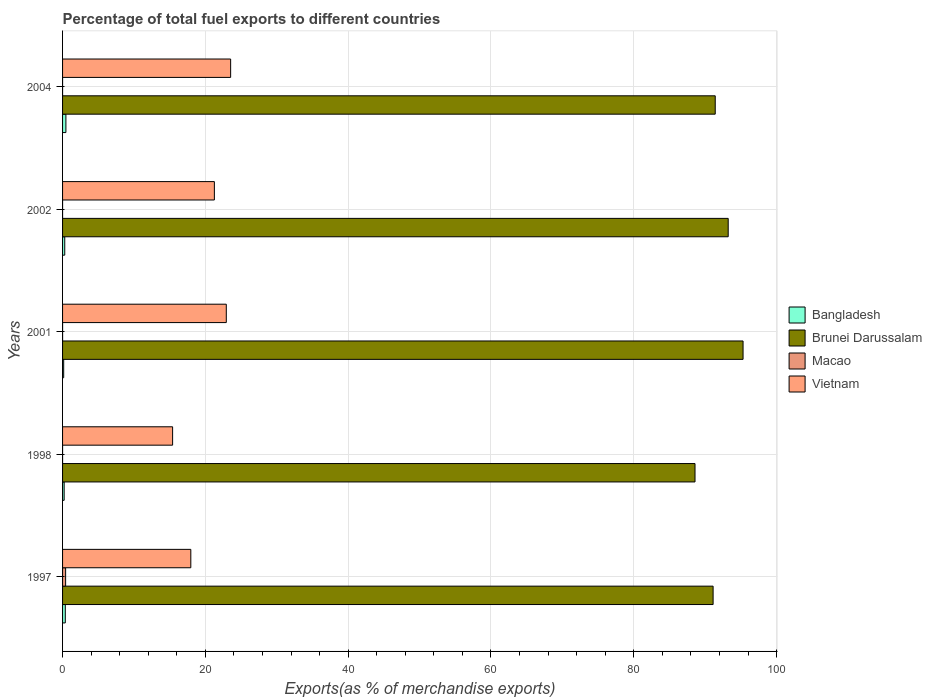How many different coloured bars are there?
Keep it short and to the point. 4. How many groups of bars are there?
Offer a terse response. 5. Are the number of bars on each tick of the Y-axis equal?
Give a very brief answer. Yes. How many bars are there on the 5th tick from the top?
Make the answer very short. 4. What is the percentage of exports to different countries in Macao in 2002?
Offer a terse response. 3.47856806115449e-5. Across all years, what is the maximum percentage of exports to different countries in Brunei Darussalam?
Offer a very short reply. 95.31. Across all years, what is the minimum percentage of exports to different countries in Macao?
Your response must be concise. 1.48205792325693e-5. What is the total percentage of exports to different countries in Macao in the graph?
Offer a terse response. 0.43. What is the difference between the percentage of exports to different countries in Vietnam in 1998 and that in 2004?
Provide a succinct answer. -8.13. What is the difference between the percentage of exports to different countries in Bangladesh in 1998 and the percentage of exports to different countries in Brunei Darussalam in 2001?
Your response must be concise. -95.08. What is the average percentage of exports to different countries in Brunei Darussalam per year?
Offer a terse response. 91.93. In the year 1997, what is the difference between the percentage of exports to different countries in Vietnam and percentage of exports to different countries in Macao?
Provide a succinct answer. 17.53. In how many years, is the percentage of exports to different countries in Macao greater than 72 %?
Offer a terse response. 0. What is the ratio of the percentage of exports to different countries in Macao in 2002 to that in 2004?
Give a very brief answer. 0.46. Is the percentage of exports to different countries in Bangladesh in 1998 less than that in 2001?
Offer a terse response. No. Is the difference between the percentage of exports to different countries in Vietnam in 2001 and 2004 greater than the difference between the percentage of exports to different countries in Macao in 2001 and 2004?
Your answer should be compact. No. What is the difference between the highest and the second highest percentage of exports to different countries in Vietnam?
Provide a succinct answer. 0.61. What is the difference between the highest and the lowest percentage of exports to different countries in Macao?
Offer a very short reply. 0.43. In how many years, is the percentage of exports to different countries in Brunei Darussalam greater than the average percentage of exports to different countries in Brunei Darussalam taken over all years?
Your answer should be very brief. 2. Is the sum of the percentage of exports to different countries in Vietnam in 1997 and 2004 greater than the maximum percentage of exports to different countries in Brunei Darussalam across all years?
Give a very brief answer. No. What does the 2nd bar from the bottom in 1998 represents?
Your response must be concise. Brunei Darussalam. Is it the case that in every year, the sum of the percentage of exports to different countries in Macao and percentage of exports to different countries in Bangladesh is greater than the percentage of exports to different countries in Vietnam?
Provide a succinct answer. No. Are all the bars in the graph horizontal?
Give a very brief answer. Yes. How many years are there in the graph?
Keep it short and to the point. 5. What is the difference between two consecutive major ticks on the X-axis?
Keep it short and to the point. 20. Are the values on the major ticks of X-axis written in scientific E-notation?
Provide a short and direct response. No. Where does the legend appear in the graph?
Offer a terse response. Center right. How many legend labels are there?
Offer a very short reply. 4. How are the legend labels stacked?
Provide a short and direct response. Vertical. What is the title of the graph?
Keep it short and to the point. Percentage of total fuel exports to different countries. What is the label or title of the X-axis?
Provide a succinct answer. Exports(as % of merchandise exports). What is the Exports(as % of merchandise exports) in Bangladesh in 1997?
Provide a succinct answer. 0.38. What is the Exports(as % of merchandise exports) in Brunei Darussalam in 1997?
Ensure brevity in your answer.  91.11. What is the Exports(as % of merchandise exports) in Macao in 1997?
Your response must be concise. 0.43. What is the Exports(as % of merchandise exports) of Vietnam in 1997?
Give a very brief answer. 17.96. What is the Exports(as % of merchandise exports) of Bangladesh in 1998?
Make the answer very short. 0.22. What is the Exports(as % of merchandise exports) in Brunei Darussalam in 1998?
Ensure brevity in your answer.  88.58. What is the Exports(as % of merchandise exports) in Macao in 1998?
Your answer should be very brief. 1.48205792325693e-5. What is the Exports(as % of merchandise exports) in Vietnam in 1998?
Offer a terse response. 15.41. What is the Exports(as % of merchandise exports) in Bangladesh in 2001?
Provide a succinct answer. 0.16. What is the Exports(as % of merchandise exports) of Brunei Darussalam in 2001?
Offer a very short reply. 95.31. What is the Exports(as % of merchandise exports) of Macao in 2001?
Provide a short and direct response. 0. What is the Exports(as % of merchandise exports) of Vietnam in 2001?
Give a very brief answer. 22.93. What is the Exports(as % of merchandise exports) of Bangladesh in 2002?
Offer a very short reply. 0.31. What is the Exports(as % of merchandise exports) of Brunei Darussalam in 2002?
Provide a succinct answer. 93.23. What is the Exports(as % of merchandise exports) in Macao in 2002?
Your answer should be compact. 3.47856806115449e-5. What is the Exports(as % of merchandise exports) of Vietnam in 2002?
Keep it short and to the point. 21.26. What is the Exports(as % of merchandise exports) in Bangladesh in 2004?
Your answer should be compact. 0.47. What is the Exports(as % of merchandise exports) of Brunei Darussalam in 2004?
Provide a short and direct response. 91.41. What is the Exports(as % of merchandise exports) in Macao in 2004?
Offer a terse response. 7.553903566299259e-5. What is the Exports(as % of merchandise exports) in Vietnam in 2004?
Your answer should be compact. 23.54. Across all years, what is the maximum Exports(as % of merchandise exports) of Bangladesh?
Ensure brevity in your answer.  0.47. Across all years, what is the maximum Exports(as % of merchandise exports) in Brunei Darussalam?
Provide a short and direct response. 95.31. Across all years, what is the maximum Exports(as % of merchandise exports) of Macao?
Keep it short and to the point. 0.43. Across all years, what is the maximum Exports(as % of merchandise exports) of Vietnam?
Provide a short and direct response. 23.54. Across all years, what is the minimum Exports(as % of merchandise exports) of Bangladesh?
Offer a terse response. 0.16. Across all years, what is the minimum Exports(as % of merchandise exports) of Brunei Darussalam?
Ensure brevity in your answer.  88.58. Across all years, what is the minimum Exports(as % of merchandise exports) in Macao?
Your answer should be compact. 1.48205792325693e-5. Across all years, what is the minimum Exports(as % of merchandise exports) in Vietnam?
Your answer should be compact. 15.41. What is the total Exports(as % of merchandise exports) in Bangladesh in the graph?
Offer a terse response. 1.54. What is the total Exports(as % of merchandise exports) in Brunei Darussalam in the graph?
Make the answer very short. 459.63. What is the total Exports(as % of merchandise exports) in Macao in the graph?
Your answer should be compact. 0.43. What is the total Exports(as % of merchandise exports) in Vietnam in the graph?
Keep it short and to the point. 101.11. What is the difference between the Exports(as % of merchandise exports) in Bangladesh in 1997 and that in 1998?
Ensure brevity in your answer.  0.16. What is the difference between the Exports(as % of merchandise exports) in Brunei Darussalam in 1997 and that in 1998?
Offer a very short reply. 2.53. What is the difference between the Exports(as % of merchandise exports) of Macao in 1997 and that in 1998?
Ensure brevity in your answer.  0.43. What is the difference between the Exports(as % of merchandise exports) of Vietnam in 1997 and that in 1998?
Provide a short and direct response. 2.55. What is the difference between the Exports(as % of merchandise exports) of Bangladesh in 1997 and that in 2001?
Provide a succinct answer. 0.23. What is the difference between the Exports(as % of merchandise exports) in Brunei Darussalam in 1997 and that in 2001?
Give a very brief answer. -4.19. What is the difference between the Exports(as % of merchandise exports) of Macao in 1997 and that in 2001?
Make the answer very short. 0.43. What is the difference between the Exports(as % of merchandise exports) of Vietnam in 1997 and that in 2001?
Make the answer very short. -4.97. What is the difference between the Exports(as % of merchandise exports) of Bangladesh in 1997 and that in 2002?
Make the answer very short. 0.08. What is the difference between the Exports(as % of merchandise exports) in Brunei Darussalam in 1997 and that in 2002?
Your response must be concise. -2.11. What is the difference between the Exports(as % of merchandise exports) in Macao in 1997 and that in 2002?
Your answer should be very brief. 0.43. What is the difference between the Exports(as % of merchandise exports) in Vietnam in 1997 and that in 2002?
Give a very brief answer. -3.3. What is the difference between the Exports(as % of merchandise exports) in Bangladesh in 1997 and that in 2004?
Your answer should be very brief. -0.09. What is the difference between the Exports(as % of merchandise exports) of Brunei Darussalam in 1997 and that in 2004?
Offer a terse response. -0.3. What is the difference between the Exports(as % of merchandise exports) of Macao in 1997 and that in 2004?
Your answer should be very brief. 0.43. What is the difference between the Exports(as % of merchandise exports) of Vietnam in 1997 and that in 2004?
Keep it short and to the point. -5.58. What is the difference between the Exports(as % of merchandise exports) in Bangladesh in 1998 and that in 2001?
Offer a very short reply. 0.07. What is the difference between the Exports(as % of merchandise exports) in Brunei Darussalam in 1998 and that in 2001?
Provide a succinct answer. -6.73. What is the difference between the Exports(as % of merchandise exports) in Macao in 1998 and that in 2001?
Offer a very short reply. -0. What is the difference between the Exports(as % of merchandise exports) in Vietnam in 1998 and that in 2001?
Give a very brief answer. -7.52. What is the difference between the Exports(as % of merchandise exports) of Bangladesh in 1998 and that in 2002?
Provide a succinct answer. -0.08. What is the difference between the Exports(as % of merchandise exports) of Brunei Darussalam in 1998 and that in 2002?
Keep it short and to the point. -4.65. What is the difference between the Exports(as % of merchandise exports) in Vietnam in 1998 and that in 2002?
Your response must be concise. -5.85. What is the difference between the Exports(as % of merchandise exports) of Bangladesh in 1998 and that in 2004?
Offer a very short reply. -0.25. What is the difference between the Exports(as % of merchandise exports) of Brunei Darussalam in 1998 and that in 2004?
Offer a very short reply. -2.83. What is the difference between the Exports(as % of merchandise exports) in Macao in 1998 and that in 2004?
Your answer should be very brief. -0. What is the difference between the Exports(as % of merchandise exports) of Vietnam in 1998 and that in 2004?
Provide a short and direct response. -8.13. What is the difference between the Exports(as % of merchandise exports) of Bangladesh in 2001 and that in 2002?
Ensure brevity in your answer.  -0.15. What is the difference between the Exports(as % of merchandise exports) in Brunei Darussalam in 2001 and that in 2002?
Make the answer very short. 2.08. What is the difference between the Exports(as % of merchandise exports) in Macao in 2001 and that in 2002?
Provide a succinct answer. 0. What is the difference between the Exports(as % of merchandise exports) of Vietnam in 2001 and that in 2002?
Offer a very short reply. 1.67. What is the difference between the Exports(as % of merchandise exports) of Bangladesh in 2001 and that in 2004?
Offer a very short reply. -0.31. What is the difference between the Exports(as % of merchandise exports) of Brunei Darussalam in 2001 and that in 2004?
Offer a very short reply. 3.9. What is the difference between the Exports(as % of merchandise exports) of Vietnam in 2001 and that in 2004?
Provide a short and direct response. -0.61. What is the difference between the Exports(as % of merchandise exports) in Bangladesh in 2002 and that in 2004?
Provide a short and direct response. -0.16. What is the difference between the Exports(as % of merchandise exports) of Brunei Darussalam in 2002 and that in 2004?
Offer a very short reply. 1.82. What is the difference between the Exports(as % of merchandise exports) of Vietnam in 2002 and that in 2004?
Give a very brief answer. -2.28. What is the difference between the Exports(as % of merchandise exports) of Bangladesh in 1997 and the Exports(as % of merchandise exports) of Brunei Darussalam in 1998?
Ensure brevity in your answer.  -88.19. What is the difference between the Exports(as % of merchandise exports) in Bangladesh in 1997 and the Exports(as % of merchandise exports) in Macao in 1998?
Your answer should be very brief. 0.38. What is the difference between the Exports(as % of merchandise exports) in Bangladesh in 1997 and the Exports(as % of merchandise exports) in Vietnam in 1998?
Provide a short and direct response. -15.03. What is the difference between the Exports(as % of merchandise exports) of Brunei Darussalam in 1997 and the Exports(as % of merchandise exports) of Macao in 1998?
Provide a succinct answer. 91.11. What is the difference between the Exports(as % of merchandise exports) of Brunei Darussalam in 1997 and the Exports(as % of merchandise exports) of Vietnam in 1998?
Provide a short and direct response. 75.7. What is the difference between the Exports(as % of merchandise exports) in Macao in 1997 and the Exports(as % of merchandise exports) in Vietnam in 1998?
Offer a terse response. -14.99. What is the difference between the Exports(as % of merchandise exports) in Bangladesh in 1997 and the Exports(as % of merchandise exports) in Brunei Darussalam in 2001?
Your answer should be compact. -94.92. What is the difference between the Exports(as % of merchandise exports) of Bangladesh in 1997 and the Exports(as % of merchandise exports) of Macao in 2001?
Ensure brevity in your answer.  0.38. What is the difference between the Exports(as % of merchandise exports) of Bangladesh in 1997 and the Exports(as % of merchandise exports) of Vietnam in 2001?
Ensure brevity in your answer.  -22.55. What is the difference between the Exports(as % of merchandise exports) in Brunei Darussalam in 1997 and the Exports(as % of merchandise exports) in Macao in 2001?
Keep it short and to the point. 91.11. What is the difference between the Exports(as % of merchandise exports) of Brunei Darussalam in 1997 and the Exports(as % of merchandise exports) of Vietnam in 2001?
Provide a short and direct response. 68.18. What is the difference between the Exports(as % of merchandise exports) in Macao in 1997 and the Exports(as % of merchandise exports) in Vietnam in 2001?
Offer a very short reply. -22.5. What is the difference between the Exports(as % of merchandise exports) in Bangladesh in 1997 and the Exports(as % of merchandise exports) in Brunei Darussalam in 2002?
Your answer should be very brief. -92.84. What is the difference between the Exports(as % of merchandise exports) of Bangladesh in 1997 and the Exports(as % of merchandise exports) of Macao in 2002?
Ensure brevity in your answer.  0.38. What is the difference between the Exports(as % of merchandise exports) in Bangladesh in 1997 and the Exports(as % of merchandise exports) in Vietnam in 2002?
Make the answer very short. -20.88. What is the difference between the Exports(as % of merchandise exports) in Brunei Darussalam in 1997 and the Exports(as % of merchandise exports) in Macao in 2002?
Your answer should be compact. 91.11. What is the difference between the Exports(as % of merchandise exports) in Brunei Darussalam in 1997 and the Exports(as % of merchandise exports) in Vietnam in 2002?
Give a very brief answer. 69.85. What is the difference between the Exports(as % of merchandise exports) in Macao in 1997 and the Exports(as % of merchandise exports) in Vietnam in 2002?
Provide a succinct answer. -20.83. What is the difference between the Exports(as % of merchandise exports) of Bangladesh in 1997 and the Exports(as % of merchandise exports) of Brunei Darussalam in 2004?
Your answer should be very brief. -91.03. What is the difference between the Exports(as % of merchandise exports) of Bangladesh in 1997 and the Exports(as % of merchandise exports) of Macao in 2004?
Your answer should be very brief. 0.38. What is the difference between the Exports(as % of merchandise exports) in Bangladesh in 1997 and the Exports(as % of merchandise exports) in Vietnam in 2004?
Your answer should be very brief. -23.16. What is the difference between the Exports(as % of merchandise exports) of Brunei Darussalam in 1997 and the Exports(as % of merchandise exports) of Macao in 2004?
Your answer should be very brief. 91.11. What is the difference between the Exports(as % of merchandise exports) of Brunei Darussalam in 1997 and the Exports(as % of merchandise exports) of Vietnam in 2004?
Give a very brief answer. 67.57. What is the difference between the Exports(as % of merchandise exports) in Macao in 1997 and the Exports(as % of merchandise exports) in Vietnam in 2004?
Give a very brief answer. -23.11. What is the difference between the Exports(as % of merchandise exports) in Bangladesh in 1998 and the Exports(as % of merchandise exports) in Brunei Darussalam in 2001?
Your answer should be very brief. -95.08. What is the difference between the Exports(as % of merchandise exports) in Bangladesh in 1998 and the Exports(as % of merchandise exports) in Macao in 2001?
Offer a very short reply. 0.22. What is the difference between the Exports(as % of merchandise exports) in Bangladesh in 1998 and the Exports(as % of merchandise exports) in Vietnam in 2001?
Provide a short and direct response. -22.71. What is the difference between the Exports(as % of merchandise exports) in Brunei Darussalam in 1998 and the Exports(as % of merchandise exports) in Macao in 2001?
Provide a succinct answer. 88.58. What is the difference between the Exports(as % of merchandise exports) of Brunei Darussalam in 1998 and the Exports(as % of merchandise exports) of Vietnam in 2001?
Ensure brevity in your answer.  65.65. What is the difference between the Exports(as % of merchandise exports) in Macao in 1998 and the Exports(as % of merchandise exports) in Vietnam in 2001?
Ensure brevity in your answer.  -22.93. What is the difference between the Exports(as % of merchandise exports) of Bangladesh in 1998 and the Exports(as % of merchandise exports) of Brunei Darussalam in 2002?
Provide a succinct answer. -93. What is the difference between the Exports(as % of merchandise exports) in Bangladesh in 1998 and the Exports(as % of merchandise exports) in Macao in 2002?
Keep it short and to the point. 0.22. What is the difference between the Exports(as % of merchandise exports) in Bangladesh in 1998 and the Exports(as % of merchandise exports) in Vietnam in 2002?
Give a very brief answer. -21.04. What is the difference between the Exports(as % of merchandise exports) in Brunei Darussalam in 1998 and the Exports(as % of merchandise exports) in Macao in 2002?
Offer a terse response. 88.58. What is the difference between the Exports(as % of merchandise exports) of Brunei Darussalam in 1998 and the Exports(as % of merchandise exports) of Vietnam in 2002?
Provide a short and direct response. 67.31. What is the difference between the Exports(as % of merchandise exports) in Macao in 1998 and the Exports(as % of merchandise exports) in Vietnam in 2002?
Your answer should be very brief. -21.26. What is the difference between the Exports(as % of merchandise exports) of Bangladesh in 1998 and the Exports(as % of merchandise exports) of Brunei Darussalam in 2004?
Provide a short and direct response. -91.19. What is the difference between the Exports(as % of merchandise exports) in Bangladesh in 1998 and the Exports(as % of merchandise exports) in Macao in 2004?
Your answer should be compact. 0.22. What is the difference between the Exports(as % of merchandise exports) in Bangladesh in 1998 and the Exports(as % of merchandise exports) in Vietnam in 2004?
Offer a very short reply. -23.32. What is the difference between the Exports(as % of merchandise exports) of Brunei Darussalam in 1998 and the Exports(as % of merchandise exports) of Macao in 2004?
Give a very brief answer. 88.58. What is the difference between the Exports(as % of merchandise exports) in Brunei Darussalam in 1998 and the Exports(as % of merchandise exports) in Vietnam in 2004?
Your response must be concise. 65.04. What is the difference between the Exports(as % of merchandise exports) of Macao in 1998 and the Exports(as % of merchandise exports) of Vietnam in 2004?
Provide a succinct answer. -23.54. What is the difference between the Exports(as % of merchandise exports) in Bangladesh in 2001 and the Exports(as % of merchandise exports) in Brunei Darussalam in 2002?
Provide a short and direct response. -93.07. What is the difference between the Exports(as % of merchandise exports) in Bangladesh in 2001 and the Exports(as % of merchandise exports) in Macao in 2002?
Your answer should be very brief. 0.16. What is the difference between the Exports(as % of merchandise exports) in Bangladesh in 2001 and the Exports(as % of merchandise exports) in Vietnam in 2002?
Your answer should be compact. -21.11. What is the difference between the Exports(as % of merchandise exports) of Brunei Darussalam in 2001 and the Exports(as % of merchandise exports) of Macao in 2002?
Provide a short and direct response. 95.31. What is the difference between the Exports(as % of merchandise exports) in Brunei Darussalam in 2001 and the Exports(as % of merchandise exports) in Vietnam in 2002?
Give a very brief answer. 74.04. What is the difference between the Exports(as % of merchandise exports) of Macao in 2001 and the Exports(as % of merchandise exports) of Vietnam in 2002?
Your answer should be compact. -21.26. What is the difference between the Exports(as % of merchandise exports) in Bangladesh in 2001 and the Exports(as % of merchandise exports) in Brunei Darussalam in 2004?
Your answer should be very brief. -91.25. What is the difference between the Exports(as % of merchandise exports) of Bangladesh in 2001 and the Exports(as % of merchandise exports) of Macao in 2004?
Offer a terse response. 0.16. What is the difference between the Exports(as % of merchandise exports) of Bangladesh in 2001 and the Exports(as % of merchandise exports) of Vietnam in 2004?
Offer a terse response. -23.38. What is the difference between the Exports(as % of merchandise exports) in Brunei Darussalam in 2001 and the Exports(as % of merchandise exports) in Macao in 2004?
Make the answer very short. 95.31. What is the difference between the Exports(as % of merchandise exports) in Brunei Darussalam in 2001 and the Exports(as % of merchandise exports) in Vietnam in 2004?
Offer a terse response. 71.77. What is the difference between the Exports(as % of merchandise exports) of Macao in 2001 and the Exports(as % of merchandise exports) of Vietnam in 2004?
Keep it short and to the point. -23.54. What is the difference between the Exports(as % of merchandise exports) in Bangladesh in 2002 and the Exports(as % of merchandise exports) in Brunei Darussalam in 2004?
Provide a succinct answer. -91.1. What is the difference between the Exports(as % of merchandise exports) of Bangladesh in 2002 and the Exports(as % of merchandise exports) of Macao in 2004?
Keep it short and to the point. 0.31. What is the difference between the Exports(as % of merchandise exports) in Bangladesh in 2002 and the Exports(as % of merchandise exports) in Vietnam in 2004?
Offer a very short reply. -23.23. What is the difference between the Exports(as % of merchandise exports) of Brunei Darussalam in 2002 and the Exports(as % of merchandise exports) of Macao in 2004?
Provide a succinct answer. 93.23. What is the difference between the Exports(as % of merchandise exports) in Brunei Darussalam in 2002 and the Exports(as % of merchandise exports) in Vietnam in 2004?
Your answer should be very brief. 69.69. What is the difference between the Exports(as % of merchandise exports) of Macao in 2002 and the Exports(as % of merchandise exports) of Vietnam in 2004?
Provide a succinct answer. -23.54. What is the average Exports(as % of merchandise exports) in Bangladesh per year?
Provide a succinct answer. 0.31. What is the average Exports(as % of merchandise exports) in Brunei Darussalam per year?
Your answer should be very brief. 91.93. What is the average Exports(as % of merchandise exports) of Macao per year?
Keep it short and to the point. 0.09. What is the average Exports(as % of merchandise exports) in Vietnam per year?
Offer a terse response. 20.22. In the year 1997, what is the difference between the Exports(as % of merchandise exports) in Bangladesh and Exports(as % of merchandise exports) in Brunei Darussalam?
Provide a succinct answer. -90.73. In the year 1997, what is the difference between the Exports(as % of merchandise exports) in Bangladesh and Exports(as % of merchandise exports) in Macao?
Ensure brevity in your answer.  -0.04. In the year 1997, what is the difference between the Exports(as % of merchandise exports) in Bangladesh and Exports(as % of merchandise exports) in Vietnam?
Give a very brief answer. -17.58. In the year 1997, what is the difference between the Exports(as % of merchandise exports) of Brunei Darussalam and Exports(as % of merchandise exports) of Macao?
Ensure brevity in your answer.  90.68. In the year 1997, what is the difference between the Exports(as % of merchandise exports) in Brunei Darussalam and Exports(as % of merchandise exports) in Vietnam?
Your answer should be very brief. 73.15. In the year 1997, what is the difference between the Exports(as % of merchandise exports) of Macao and Exports(as % of merchandise exports) of Vietnam?
Your response must be concise. -17.53. In the year 1998, what is the difference between the Exports(as % of merchandise exports) in Bangladesh and Exports(as % of merchandise exports) in Brunei Darussalam?
Your response must be concise. -88.36. In the year 1998, what is the difference between the Exports(as % of merchandise exports) of Bangladesh and Exports(as % of merchandise exports) of Macao?
Offer a very short reply. 0.22. In the year 1998, what is the difference between the Exports(as % of merchandise exports) of Bangladesh and Exports(as % of merchandise exports) of Vietnam?
Give a very brief answer. -15.19. In the year 1998, what is the difference between the Exports(as % of merchandise exports) in Brunei Darussalam and Exports(as % of merchandise exports) in Macao?
Provide a succinct answer. 88.58. In the year 1998, what is the difference between the Exports(as % of merchandise exports) of Brunei Darussalam and Exports(as % of merchandise exports) of Vietnam?
Your answer should be compact. 73.16. In the year 1998, what is the difference between the Exports(as % of merchandise exports) in Macao and Exports(as % of merchandise exports) in Vietnam?
Provide a succinct answer. -15.41. In the year 2001, what is the difference between the Exports(as % of merchandise exports) of Bangladesh and Exports(as % of merchandise exports) of Brunei Darussalam?
Offer a terse response. -95.15. In the year 2001, what is the difference between the Exports(as % of merchandise exports) of Bangladesh and Exports(as % of merchandise exports) of Macao?
Provide a succinct answer. 0.15. In the year 2001, what is the difference between the Exports(as % of merchandise exports) in Bangladesh and Exports(as % of merchandise exports) in Vietnam?
Your response must be concise. -22.77. In the year 2001, what is the difference between the Exports(as % of merchandise exports) of Brunei Darussalam and Exports(as % of merchandise exports) of Macao?
Provide a succinct answer. 95.3. In the year 2001, what is the difference between the Exports(as % of merchandise exports) in Brunei Darussalam and Exports(as % of merchandise exports) in Vietnam?
Offer a very short reply. 72.38. In the year 2001, what is the difference between the Exports(as % of merchandise exports) of Macao and Exports(as % of merchandise exports) of Vietnam?
Offer a terse response. -22.93. In the year 2002, what is the difference between the Exports(as % of merchandise exports) in Bangladesh and Exports(as % of merchandise exports) in Brunei Darussalam?
Your answer should be very brief. -92.92. In the year 2002, what is the difference between the Exports(as % of merchandise exports) in Bangladesh and Exports(as % of merchandise exports) in Macao?
Ensure brevity in your answer.  0.31. In the year 2002, what is the difference between the Exports(as % of merchandise exports) in Bangladesh and Exports(as % of merchandise exports) in Vietnam?
Make the answer very short. -20.96. In the year 2002, what is the difference between the Exports(as % of merchandise exports) of Brunei Darussalam and Exports(as % of merchandise exports) of Macao?
Make the answer very short. 93.23. In the year 2002, what is the difference between the Exports(as % of merchandise exports) in Brunei Darussalam and Exports(as % of merchandise exports) in Vietnam?
Give a very brief answer. 71.96. In the year 2002, what is the difference between the Exports(as % of merchandise exports) of Macao and Exports(as % of merchandise exports) of Vietnam?
Your answer should be compact. -21.26. In the year 2004, what is the difference between the Exports(as % of merchandise exports) in Bangladesh and Exports(as % of merchandise exports) in Brunei Darussalam?
Give a very brief answer. -90.94. In the year 2004, what is the difference between the Exports(as % of merchandise exports) in Bangladesh and Exports(as % of merchandise exports) in Macao?
Your answer should be compact. 0.47. In the year 2004, what is the difference between the Exports(as % of merchandise exports) of Bangladesh and Exports(as % of merchandise exports) of Vietnam?
Provide a succinct answer. -23.07. In the year 2004, what is the difference between the Exports(as % of merchandise exports) of Brunei Darussalam and Exports(as % of merchandise exports) of Macao?
Give a very brief answer. 91.41. In the year 2004, what is the difference between the Exports(as % of merchandise exports) in Brunei Darussalam and Exports(as % of merchandise exports) in Vietnam?
Offer a very short reply. 67.87. In the year 2004, what is the difference between the Exports(as % of merchandise exports) of Macao and Exports(as % of merchandise exports) of Vietnam?
Ensure brevity in your answer.  -23.54. What is the ratio of the Exports(as % of merchandise exports) in Bangladesh in 1997 to that in 1998?
Your answer should be compact. 1.72. What is the ratio of the Exports(as % of merchandise exports) in Brunei Darussalam in 1997 to that in 1998?
Make the answer very short. 1.03. What is the ratio of the Exports(as % of merchandise exports) of Macao in 1997 to that in 1998?
Provide a succinct answer. 2.89e+04. What is the ratio of the Exports(as % of merchandise exports) in Vietnam in 1997 to that in 1998?
Keep it short and to the point. 1.17. What is the ratio of the Exports(as % of merchandise exports) of Bangladesh in 1997 to that in 2001?
Your response must be concise. 2.45. What is the ratio of the Exports(as % of merchandise exports) of Brunei Darussalam in 1997 to that in 2001?
Give a very brief answer. 0.96. What is the ratio of the Exports(as % of merchandise exports) of Macao in 1997 to that in 2001?
Your answer should be compact. 388.02. What is the ratio of the Exports(as % of merchandise exports) of Vietnam in 1997 to that in 2001?
Make the answer very short. 0.78. What is the ratio of the Exports(as % of merchandise exports) in Bangladesh in 1997 to that in 2002?
Keep it short and to the point. 1.25. What is the ratio of the Exports(as % of merchandise exports) of Brunei Darussalam in 1997 to that in 2002?
Keep it short and to the point. 0.98. What is the ratio of the Exports(as % of merchandise exports) in Macao in 1997 to that in 2002?
Ensure brevity in your answer.  1.23e+04. What is the ratio of the Exports(as % of merchandise exports) of Vietnam in 1997 to that in 2002?
Your answer should be compact. 0.84. What is the ratio of the Exports(as % of merchandise exports) in Bangladesh in 1997 to that in 2004?
Your response must be concise. 0.82. What is the ratio of the Exports(as % of merchandise exports) of Macao in 1997 to that in 2004?
Offer a terse response. 5660.42. What is the ratio of the Exports(as % of merchandise exports) in Vietnam in 1997 to that in 2004?
Make the answer very short. 0.76. What is the ratio of the Exports(as % of merchandise exports) in Bangladesh in 1998 to that in 2001?
Provide a succinct answer. 1.42. What is the ratio of the Exports(as % of merchandise exports) of Brunei Darussalam in 1998 to that in 2001?
Offer a very short reply. 0.93. What is the ratio of the Exports(as % of merchandise exports) in Macao in 1998 to that in 2001?
Ensure brevity in your answer.  0.01. What is the ratio of the Exports(as % of merchandise exports) in Vietnam in 1998 to that in 2001?
Ensure brevity in your answer.  0.67. What is the ratio of the Exports(as % of merchandise exports) in Bangladesh in 1998 to that in 2002?
Provide a succinct answer. 0.73. What is the ratio of the Exports(as % of merchandise exports) in Brunei Darussalam in 1998 to that in 2002?
Give a very brief answer. 0.95. What is the ratio of the Exports(as % of merchandise exports) of Macao in 1998 to that in 2002?
Keep it short and to the point. 0.43. What is the ratio of the Exports(as % of merchandise exports) in Vietnam in 1998 to that in 2002?
Make the answer very short. 0.72. What is the ratio of the Exports(as % of merchandise exports) of Bangladesh in 1998 to that in 2004?
Keep it short and to the point. 0.47. What is the ratio of the Exports(as % of merchandise exports) in Brunei Darussalam in 1998 to that in 2004?
Offer a terse response. 0.97. What is the ratio of the Exports(as % of merchandise exports) of Macao in 1998 to that in 2004?
Give a very brief answer. 0.2. What is the ratio of the Exports(as % of merchandise exports) of Vietnam in 1998 to that in 2004?
Offer a terse response. 0.65. What is the ratio of the Exports(as % of merchandise exports) of Bangladesh in 2001 to that in 2002?
Your response must be concise. 0.51. What is the ratio of the Exports(as % of merchandise exports) of Brunei Darussalam in 2001 to that in 2002?
Offer a very short reply. 1.02. What is the ratio of the Exports(as % of merchandise exports) of Macao in 2001 to that in 2002?
Provide a short and direct response. 31.68. What is the ratio of the Exports(as % of merchandise exports) of Vietnam in 2001 to that in 2002?
Your answer should be very brief. 1.08. What is the ratio of the Exports(as % of merchandise exports) of Bangladesh in 2001 to that in 2004?
Keep it short and to the point. 0.33. What is the ratio of the Exports(as % of merchandise exports) in Brunei Darussalam in 2001 to that in 2004?
Provide a succinct answer. 1.04. What is the ratio of the Exports(as % of merchandise exports) in Macao in 2001 to that in 2004?
Offer a very short reply. 14.59. What is the ratio of the Exports(as % of merchandise exports) in Vietnam in 2001 to that in 2004?
Your answer should be compact. 0.97. What is the ratio of the Exports(as % of merchandise exports) of Bangladesh in 2002 to that in 2004?
Make the answer very short. 0.65. What is the ratio of the Exports(as % of merchandise exports) in Brunei Darussalam in 2002 to that in 2004?
Ensure brevity in your answer.  1.02. What is the ratio of the Exports(as % of merchandise exports) of Macao in 2002 to that in 2004?
Offer a terse response. 0.46. What is the ratio of the Exports(as % of merchandise exports) in Vietnam in 2002 to that in 2004?
Give a very brief answer. 0.9. What is the difference between the highest and the second highest Exports(as % of merchandise exports) in Bangladesh?
Provide a short and direct response. 0.09. What is the difference between the highest and the second highest Exports(as % of merchandise exports) of Brunei Darussalam?
Your answer should be compact. 2.08. What is the difference between the highest and the second highest Exports(as % of merchandise exports) in Macao?
Provide a succinct answer. 0.43. What is the difference between the highest and the second highest Exports(as % of merchandise exports) of Vietnam?
Your answer should be compact. 0.61. What is the difference between the highest and the lowest Exports(as % of merchandise exports) in Bangladesh?
Your answer should be very brief. 0.31. What is the difference between the highest and the lowest Exports(as % of merchandise exports) of Brunei Darussalam?
Your answer should be compact. 6.73. What is the difference between the highest and the lowest Exports(as % of merchandise exports) in Macao?
Provide a succinct answer. 0.43. What is the difference between the highest and the lowest Exports(as % of merchandise exports) in Vietnam?
Your answer should be compact. 8.13. 